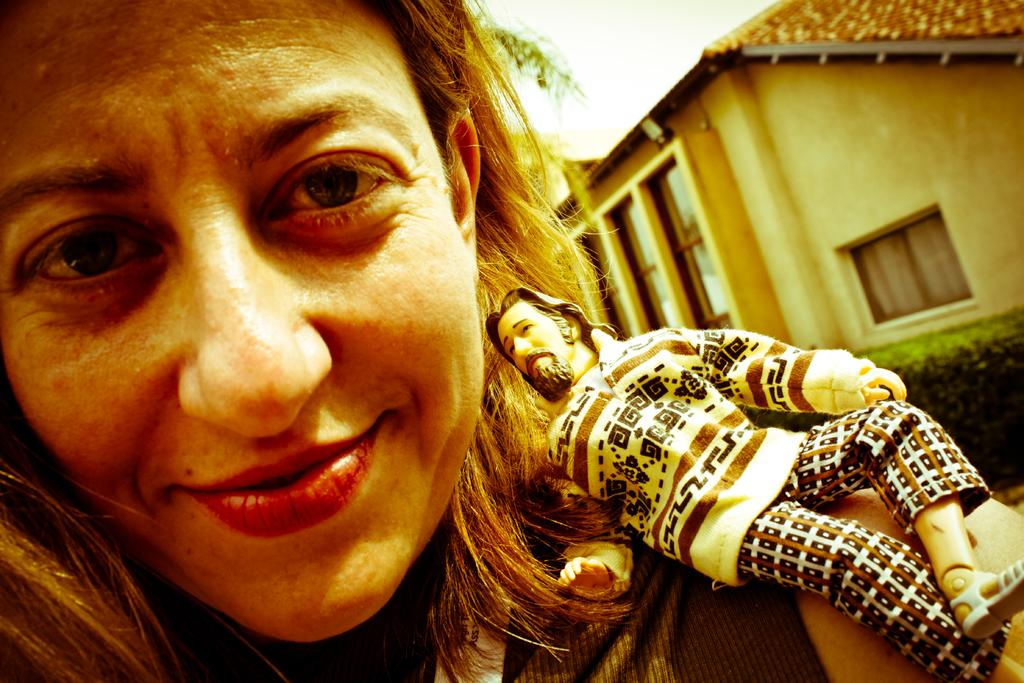Who is present in the image? There is a woman in the image. What is the woman's expression? The woman is smiling. What other object can be seen in the image? There is a toy in the image. What can be seen in the background of the image? There is a building, plants, and the sky visible in the background of the image. What type of treatment is the woman receiving in the image? There is no indication in the image that the woman is receiving any treatment. 